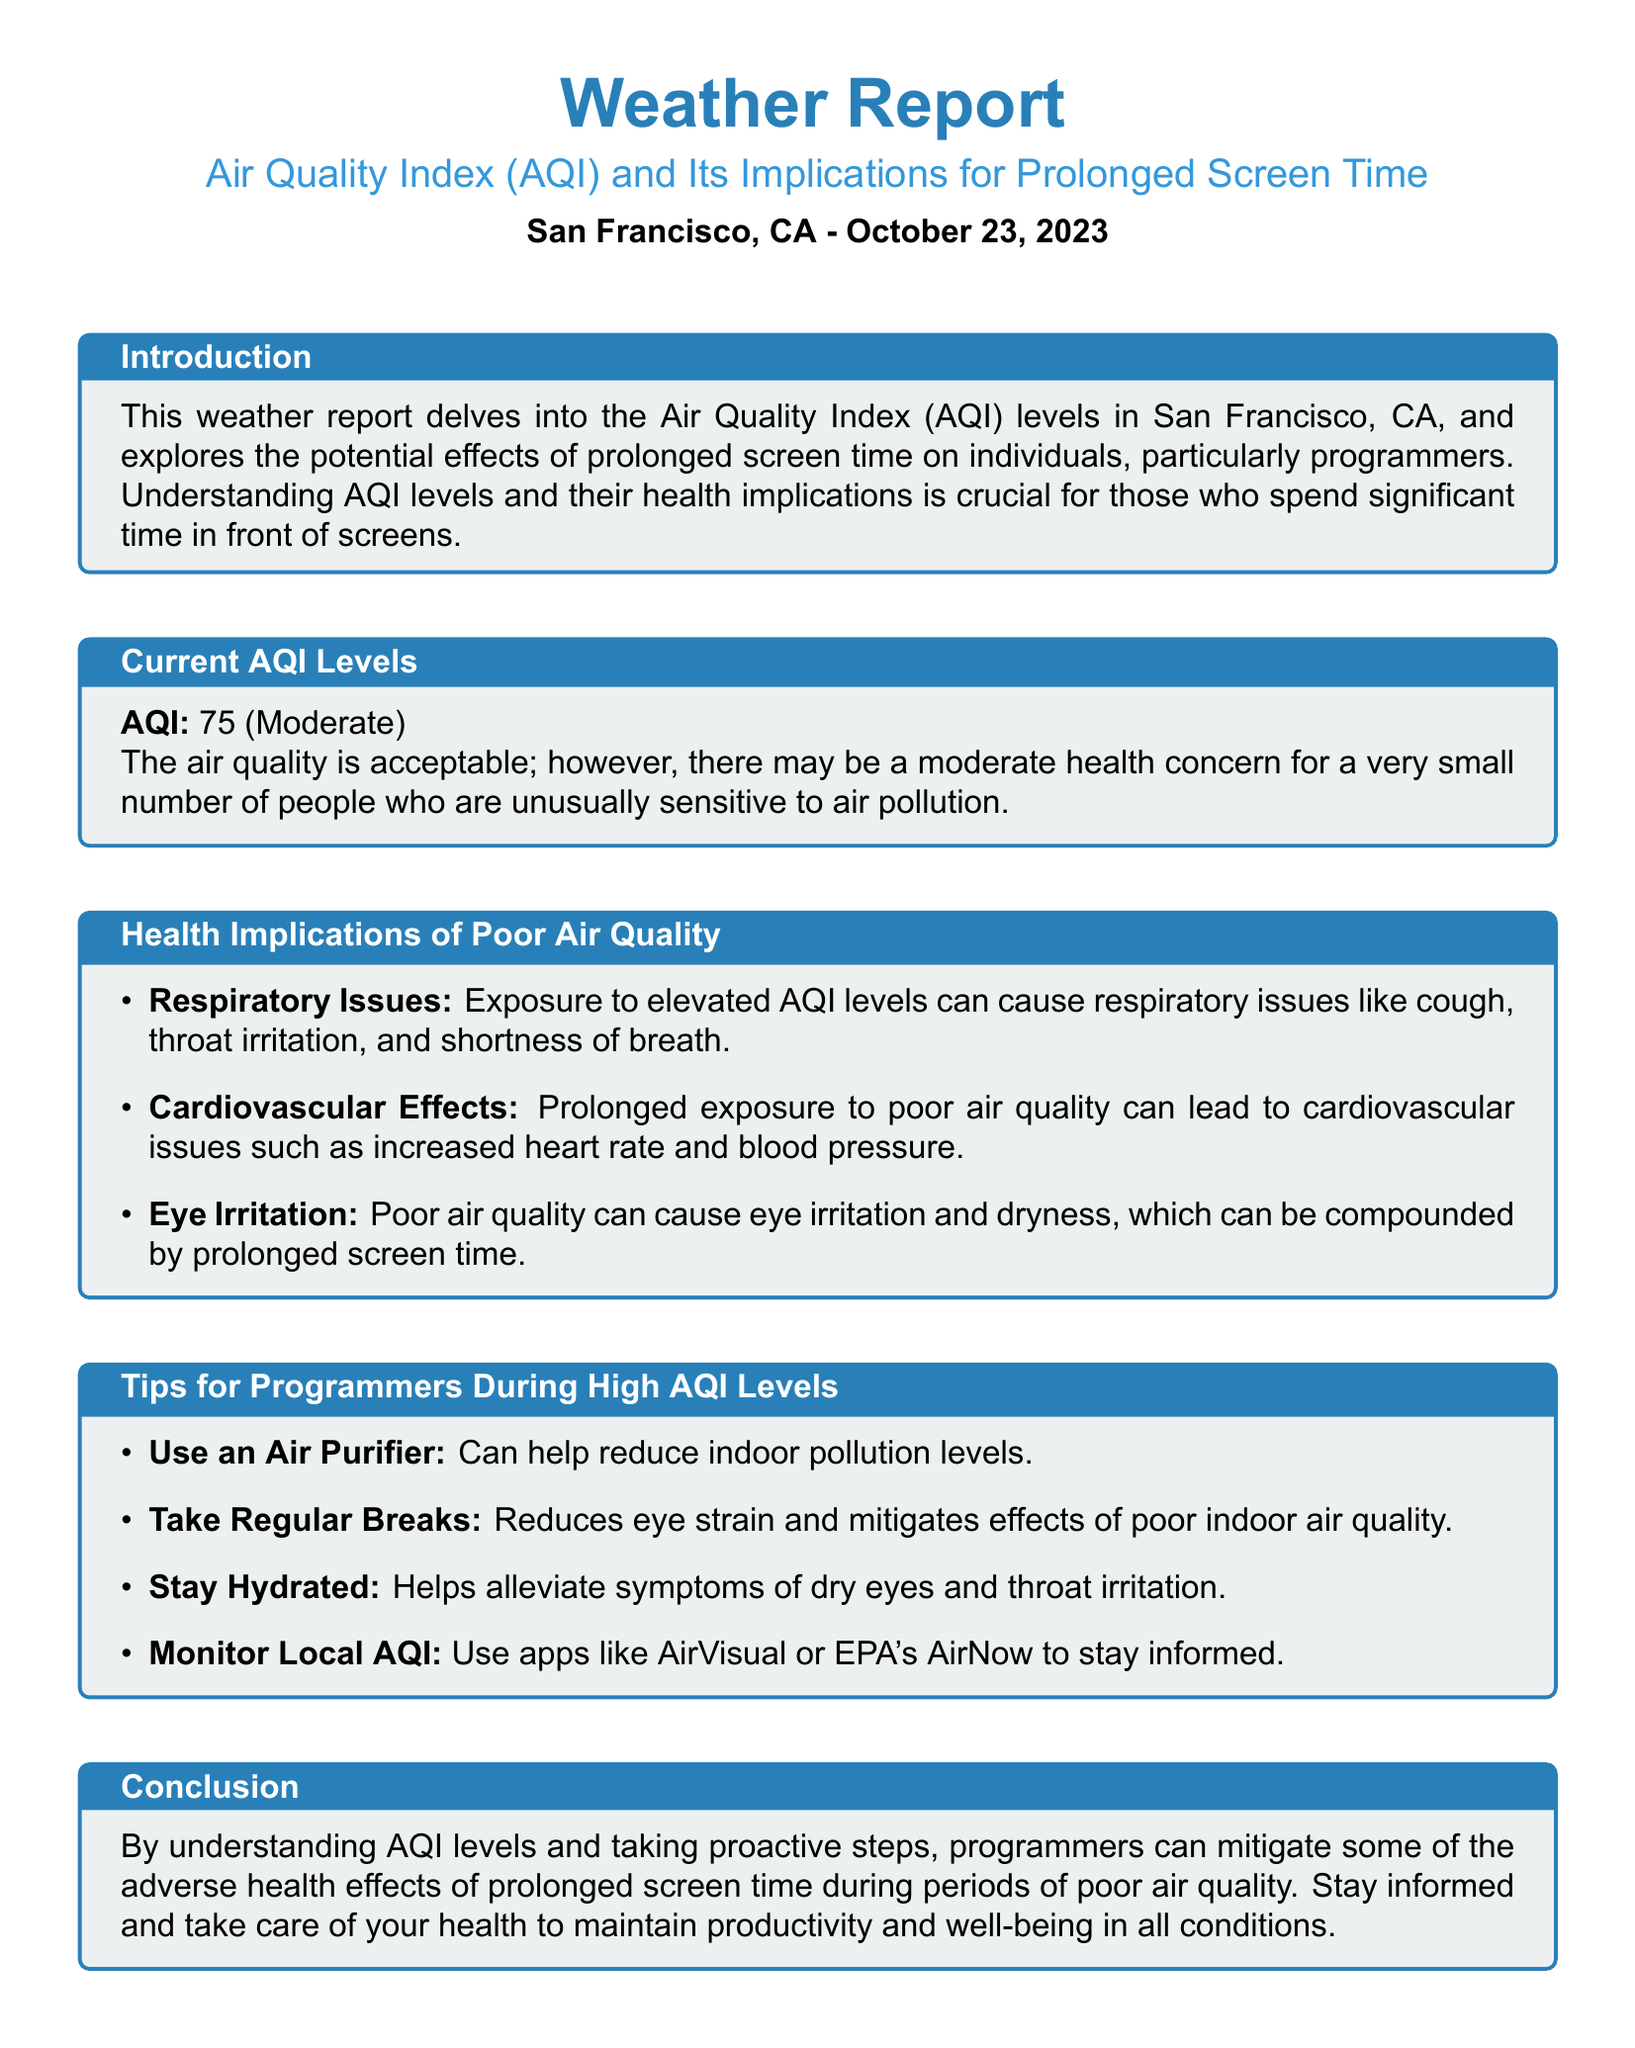What is the AQI level reported? The AQI level is stated as 75, which falls under the moderate category.
Answer: 75 What is the date of the weather report? The report specifies that it is dated October 23, 2023.
Answer: October 23, 2023 What is the health concern level for the general public according to the report? The report mentions that there may be a moderate health concern for a very small number of people.
Answer: Moderate What respiratory issues can be caused by elevated AQI levels? The report lists cough, throat irritation, and shortness of breath as respiratory issues.
Answer: Cough, throat irritation, and shortness of breath What should programmers do to alleviate symptoms of dry eyes? The document suggests staying hydrated as a tip to help alleviate symptoms.
Answer: Stay hydrated Which apps are recommended for monitoring local AQI? The report mentions AirVisual and EPA's AirNow as apps to stay informed about AQI.
Answer: AirVisual or EPA's AirNow What is one proactive step to mitigate effects of poor air quality? The document states that using an air purifier can help reduce indoor pollution levels.
Answer: Use an air purifier What is the overall implication of understanding AQI levels for programmers? According to the report, understanding AQI levels can help mitigate the adverse health effects of prolonged screen time.
Answer: Mitigate adverse health effects 